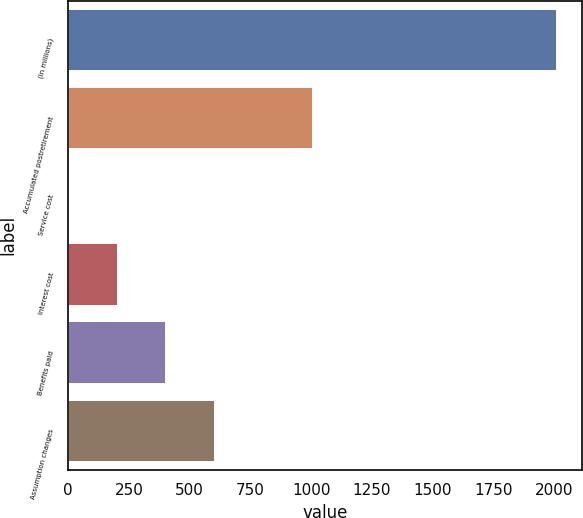<chart> <loc_0><loc_0><loc_500><loc_500><bar_chart><fcel>(in millions)<fcel>Accumulated postretirement<fcel>Service cost<fcel>Interest cost<fcel>Benefits paid<fcel>Assumption changes<nl><fcel>2014<fcel>1008<fcel>2<fcel>203.2<fcel>404.4<fcel>605.6<nl></chart> 